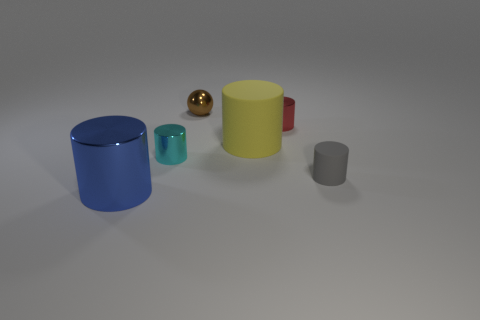What materials do the objects seem to be made of? The objects appear to be made of various materials which are simulated through different textures and lighting effects. The blue and cyan cylinders seem glossy, perhaps imitating glass or polished metal, while the yellow cylinder has a matte finish, resembling plastic or ceramic. The golden sphere looks metallic due to its reflective surface, and the small gray cylinder looks like it could be made of stone or concrete because of its rough texture. 